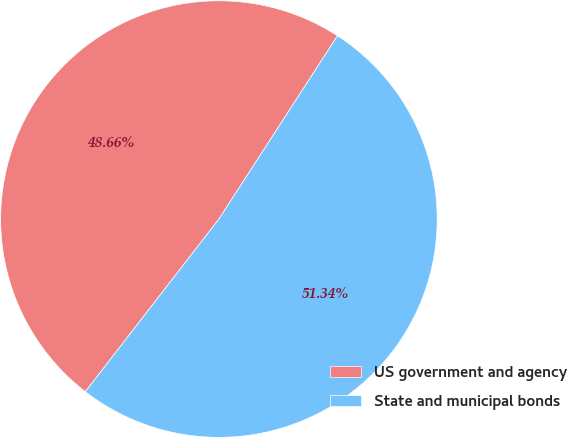<chart> <loc_0><loc_0><loc_500><loc_500><pie_chart><fcel>US government and agency<fcel>State and municipal bonds<nl><fcel>48.66%<fcel>51.34%<nl></chart> 